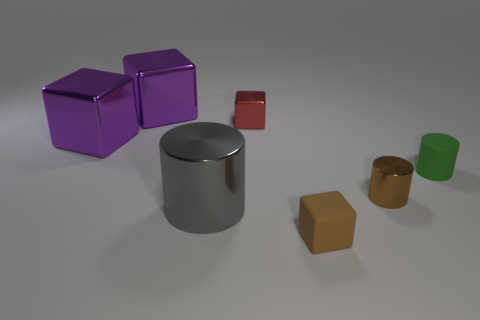Are there fewer red cubes than small gray cylinders?
Provide a short and direct response. No. Is the size of the cylinder that is to the left of the brown rubber object the same as the matte object behind the tiny brown metallic cylinder?
Ensure brevity in your answer.  No. What number of objects are brown shiny objects or purple metallic blocks?
Ensure brevity in your answer.  3. There is a brown cylinder that is in front of the small red cube; what size is it?
Your answer should be very brief. Small. How many brown cylinders are right of the brown thing on the left side of the tiny shiny thing to the right of the tiny brown block?
Your answer should be very brief. 1. Does the large metallic cylinder have the same color as the small metal cube?
Your response must be concise. No. How many metallic objects are in front of the small green cylinder and on the left side of the red thing?
Provide a short and direct response. 1. There is a brown matte object right of the red metallic object; what is its shape?
Provide a succinct answer. Cube. Is the number of things left of the tiny brown matte thing less than the number of green objects in front of the brown cylinder?
Keep it short and to the point. No. Do the cylinder that is to the left of the tiny brown cube and the tiny cube behind the small green matte cylinder have the same material?
Your answer should be very brief. Yes. 